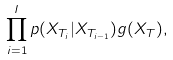Convert formula to latex. <formula><loc_0><loc_0><loc_500><loc_500>\prod _ { i = 1 } ^ { I } p ( X _ { T _ { i } } | X _ { T _ { i - 1 } } ) g ( X _ { T } ) ,</formula> 